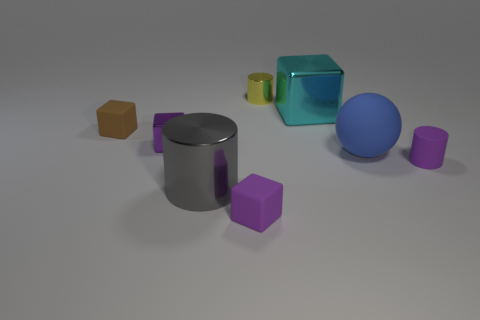Subtract all metal cylinders. How many cylinders are left? 1 Subtract all red cylinders. How many purple cubes are left? 2 Add 2 tiny blue matte objects. How many objects exist? 10 Subtract all brown blocks. How many blocks are left? 3 Subtract 0 brown cylinders. How many objects are left? 8 Subtract all balls. How many objects are left? 7 Subtract 4 blocks. How many blocks are left? 0 Subtract all red spheres. Subtract all blue cylinders. How many spheres are left? 1 Subtract all small gray rubber cylinders. Subtract all rubber cylinders. How many objects are left? 7 Add 5 purple rubber blocks. How many purple rubber blocks are left? 6 